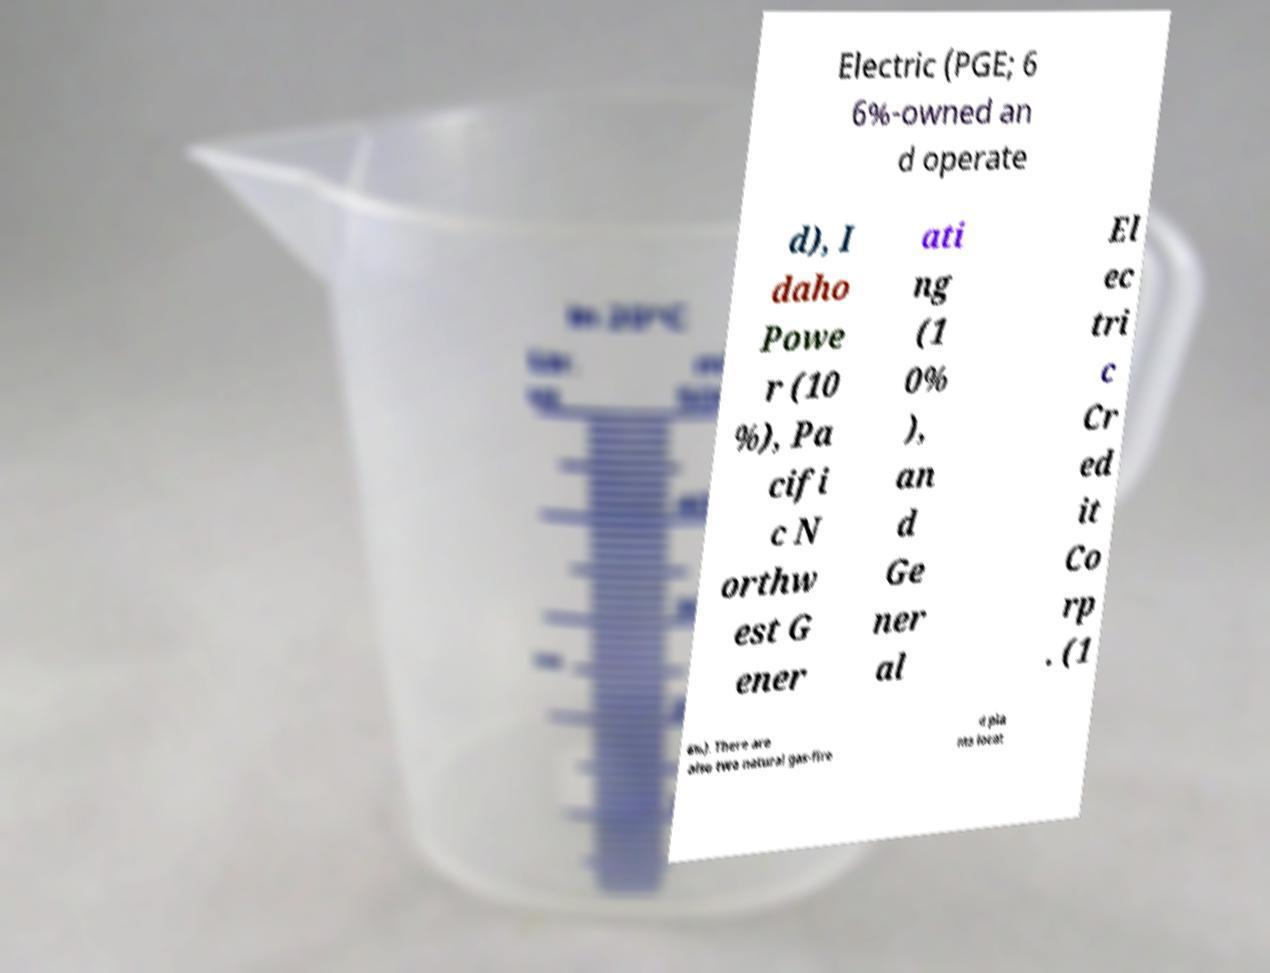There's text embedded in this image that I need extracted. Can you transcribe it verbatim? Electric (PGE; 6 6%-owned an d operate d), I daho Powe r (10 %), Pa cifi c N orthw est G ener ati ng (1 0% ), an d Ge ner al El ec tri c Cr ed it Co rp . (1 6%). There are also two natural gas-fire d pla nts locat 